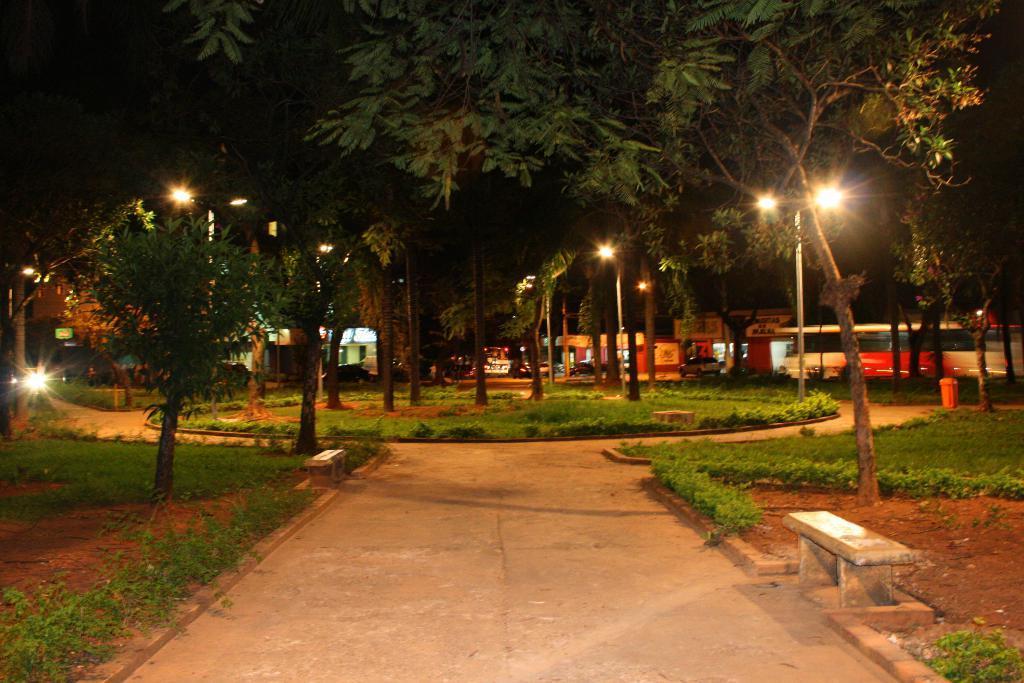How would you summarize this image in a sentence or two? In this image on the left side there's grass on the ground. There are trees and there is an empty bench and on the right side there is an empty bench and there is a tree, there is grass on the ground and there is an object which is red in colour and there are trees. In the background there are trees, poles and buildings. 